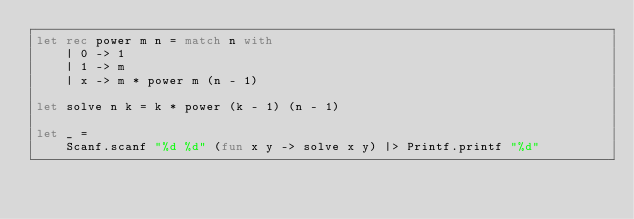Convert code to text. <code><loc_0><loc_0><loc_500><loc_500><_OCaml_>let rec power m n = match n with
	| 0 -> 1
	| 1 -> m
	| x -> m * power m (n - 1)

let solve n k = k * power (k - 1) (n - 1)

let _ =
	Scanf.scanf "%d %d" (fun x y -> solve x y) |> Printf.printf "%d"
</code> 